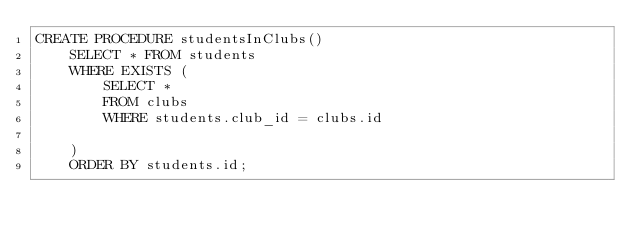<code> <loc_0><loc_0><loc_500><loc_500><_SQL_>CREATE PROCEDURE studentsInClubs()
    SELECT * FROM students
    WHERE EXISTS (
        SELECT *
        FROM clubs
        WHERE students.club_id = clubs.id
        
    )
    ORDER BY students.id;
</code> 